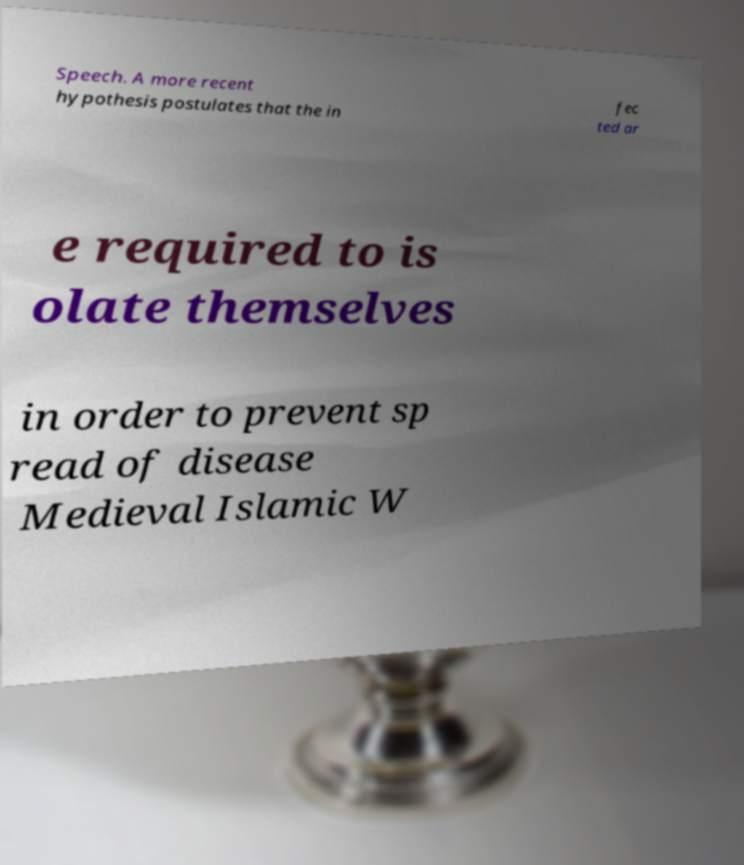Can you read and provide the text displayed in the image?This photo seems to have some interesting text. Can you extract and type it out for me? Speech. A more recent hypothesis postulates that the in fec ted ar e required to is olate themselves in order to prevent sp read of disease Medieval Islamic W 